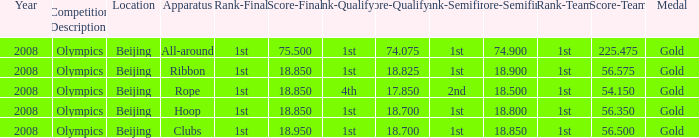On which apparatus did Kanayeva have a final score smaller than 75.5 and a qualifying score smaller than 18.7? Rope. Could you parse the entire table as a dict? {'header': ['Year', 'Competition Description', 'Location', 'Apparatus', 'Rank-Final', 'Score-Final', 'Rank-Qualifying', 'Score-Qualifying', 'Rank-Semifinal', 'Score-Semifinal', 'Rank-Team', 'Score-Team', 'Medal'], 'rows': [['2008', 'Olympics', 'Beijing', 'All-around', '1st', '75.500', '1st', '74.075', '1st', '74.900', '1st', '225.475', 'Gold'], ['2008', 'Olympics', 'Beijing', 'Ribbon', '1st', '18.850', '1st', '18.825', '1st', '18.900', '1st', '56.575', 'Gold'], ['2008', 'Olympics', 'Beijing', 'Rope', '1st', '18.850', '4th', '17.850', '2nd', '18.500', '1st', '54.150', 'Gold'], ['2008', 'Olympics', 'Beijing', 'Hoop', '1st', '18.850', '1st', '18.700', '1st', '18.800', '1st', '56.350', 'Gold'], ['2008', 'Olympics', 'Beijing', 'Clubs', '1st', '18.950', '1st', '18.700', '1st', '18.850', '1st', '56.500', 'Gold']]} 